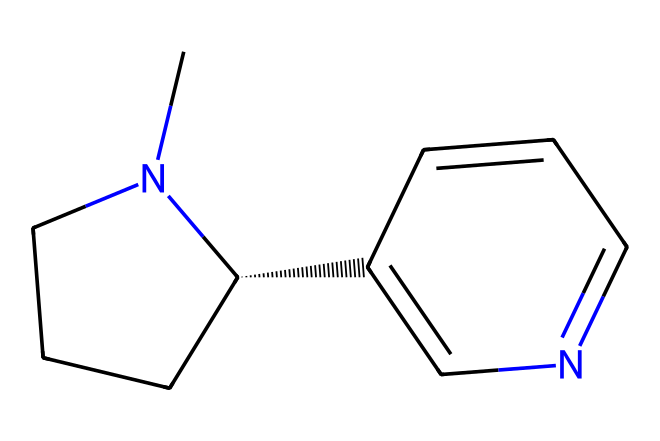What is the name of this chemical? The SMILES representation corresponds to nicotine, a well-known alkaloid. By interpreting the structure, we see the characteristic elements and arrangement that define nicotine.
Answer: nicotine How many carbon atoms are in the structure? Upon examining the SMILES, we identify the carbon atoms indicated by the “C” notation. Counting all of them, we find a total of 10 carbon atoms.
Answer: 10 How many nitrogen atoms are present in the chemical? The presence of nitrogen is indicated by the “N” in the SMILES. In this structure, counting the nitrogen atoms gives us a total of 2.
Answer: 2 What type of chemical structure is nicotine classified as? Nicotine is classified as an alkaloid, which is a category that includes compounds derived from plants, containing basic nitrogen atoms. This is evident from the nitrogen atoms present in its structure.
Answer: alkaloid What is the degree of saturation in nicotine? By analyzing the structure, we determine that nicotine is primarily unsaturated due to the presence of double bonds and rings. This means it has a degree of saturation less than that of a corresponding alkane.
Answer: unsaturated What is the functional group present in nicotine? The nitrogen atoms in the structure suggest that nicotine contains an amine functional group, which is a characteristic of most alkaloids, including nicotine itself.
Answer: amine 